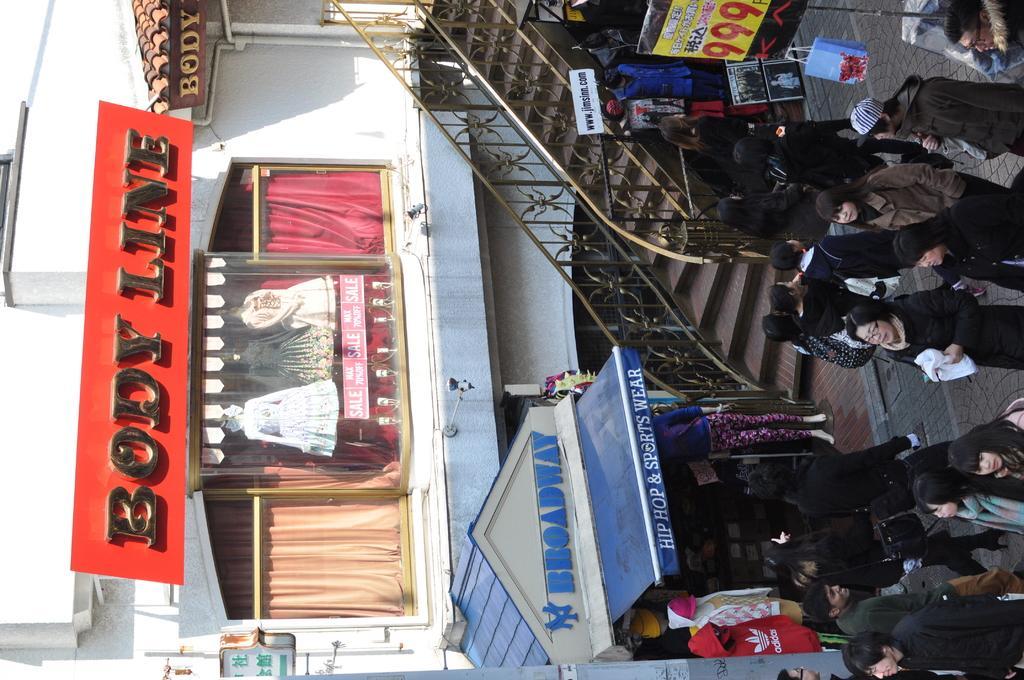How would you summarize this image in a sentence or two? This image is clicked in a street. To the right on the pavement there are many people standing and few are walking. On the top right there is a hoarding. In the center of the image there is a staircase. To the left and foreground of the image there is a building, in the building there are orange and red color curtains. In the center of the building there are mannequins and there is a hoarding named body line. 